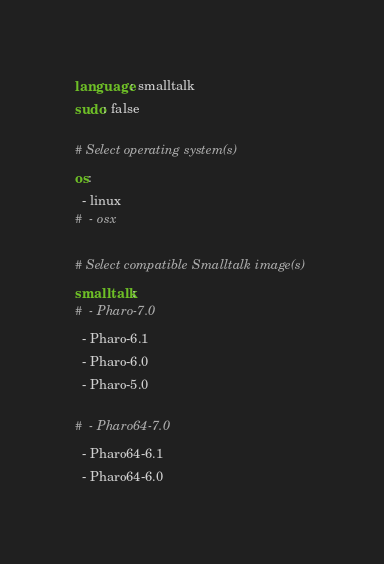<code> <loc_0><loc_0><loc_500><loc_500><_YAML_>language: smalltalk
sudo: false

# Select operating system(s)
os:
  - linux
#  - osx

# Select compatible Smalltalk image(s)
smalltalk:
#  - Pharo-7.0
  - Pharo-6.1
  - Pharo-6.0
  - Pharo-5.0

#  - Pharo64-7.0
  - Pharo64-6.1
  - Pharo64-6.0</code> 